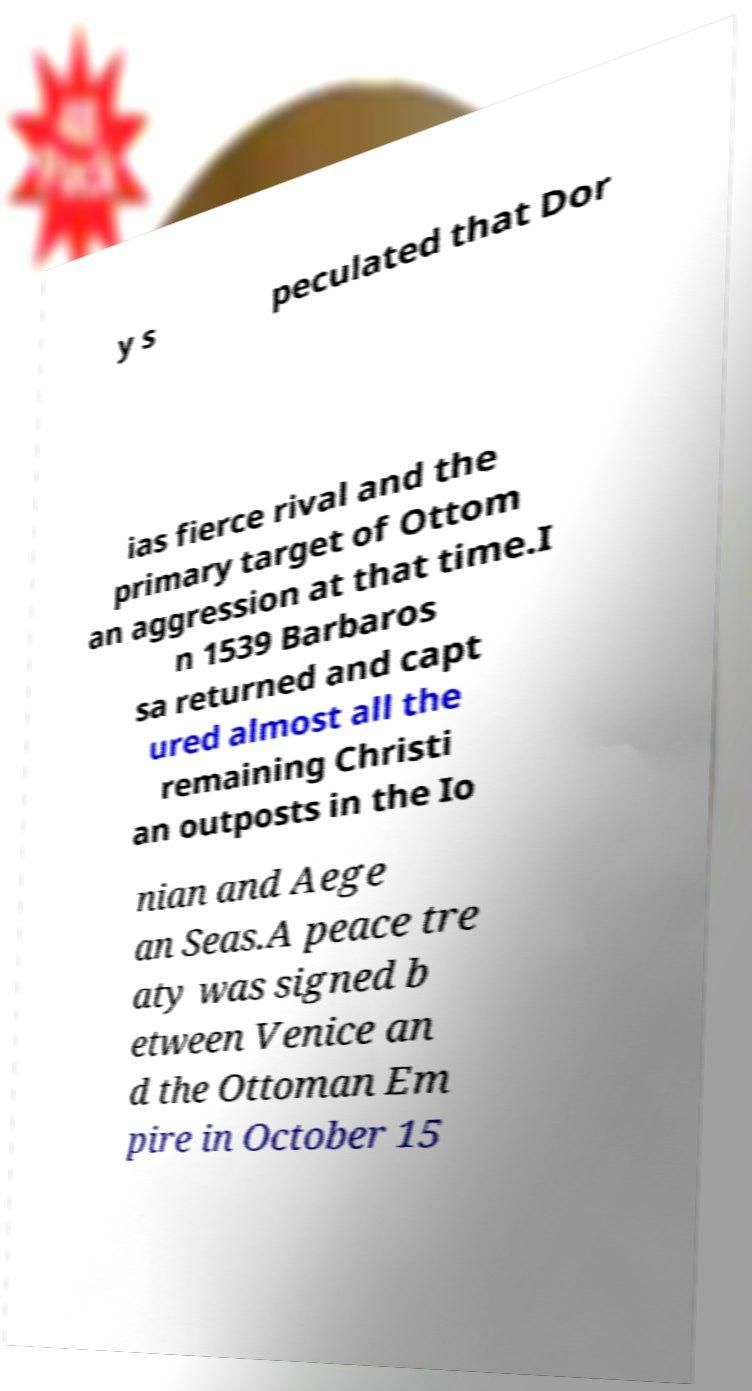Please read and relay the text visible in this image. What does it say? y s peculated that Dor ias fierce rival and the primary target of Ottom an aggression at that time.I n 1539 Barbaros sa returned and capt ured almost all the remaining Christi an outposts in the Io nian and Aege an Seas.A peace tre aty was signed b etween Venice an d the Ottoman Em pire in October 15 